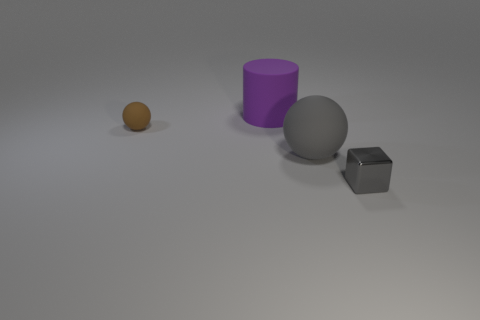Subtract 1 spheres. How many spheres are left? 1 Add 3 gray metallic objects. How many objects exist? 7 Subtract all cylinders. How many objects are left? 3 Subtract all metal blocks. Subtract all matte cylinders. How many objects are left? 2 Add 1 metal cubes. How many metal cubes are left? 2 Add 3 brown matte things. How many brown matte things exist? 4 Subtract 0 blue balls. How many objects are left? 4 Subtract all red cylinders. Subtract all brown cubes. How many cylinders are left? 1 